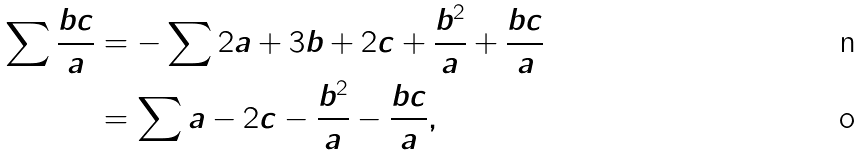<formula> <loc_0><loc_0><loc_500><loc_500>\sum \frac { b c } { a } & = - \sum 2 a + 3 b + 2 c + \frac { b ^ { 2 } } { a } + \frac { b c } { a } \\ & = \sum a - 2 c - \frac { b ^ { 2 } } { a } - \frac { b c } { a } ,</formula> 